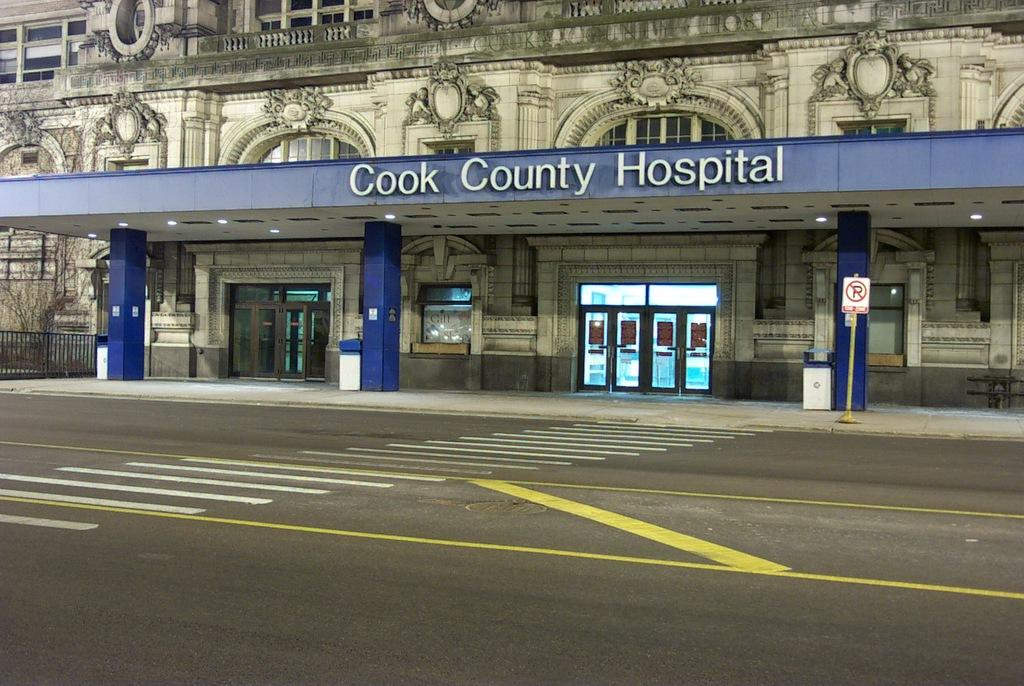<image>
Relay a brief, clear account of the picture shown. The entry for Cook County Hospital as shown in a photo from across the street. 